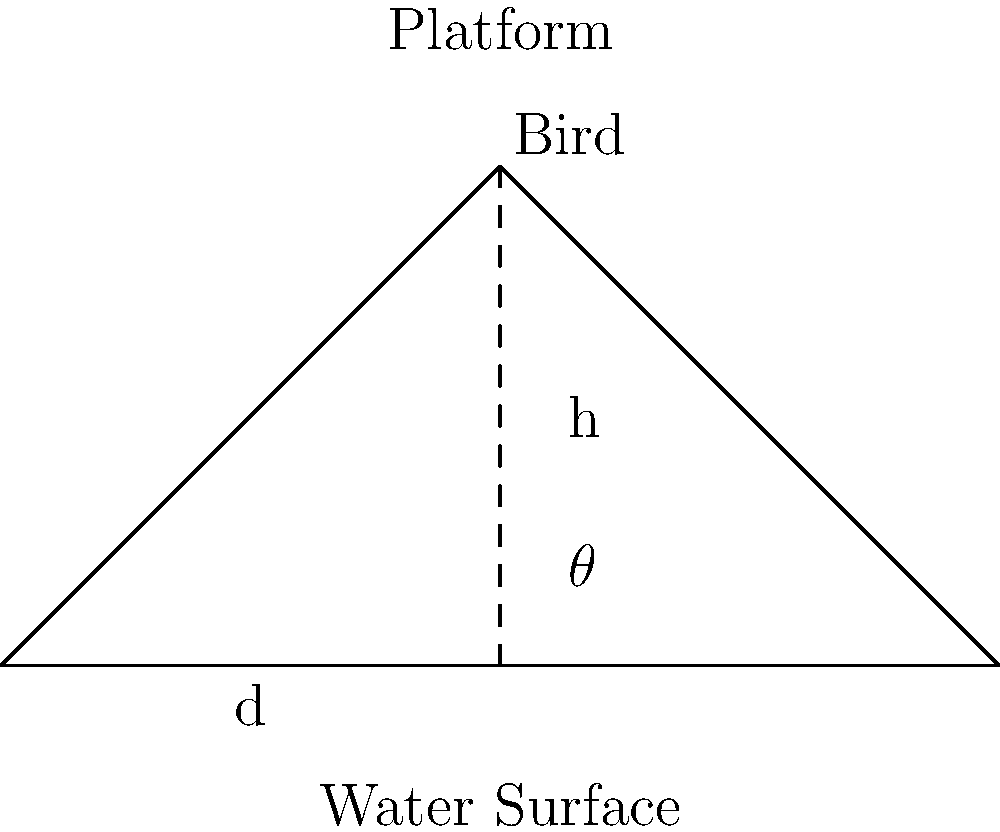From an elevated platform overlooking a lake in Winter Haven, you're observing water birds. If the platform is at a height h above the water surface and the closest observable bird is at a horizontal distance d from the base of the platform, what is the optimal viewing angle $\theta$ (in degrees) to maximize your view of the bird? To find the optimal viewing angle, we'll follow these steps:

1. Recognize that the situation forms a right-angled triangle, with:
   - The platform height (h) as the opposite side
   - The horizontal distance to the bird (d) as the adjacent side
   - The line of sight to the bird as the hypotenuse

2. The angle $\theta$ is formed between the horizontal (water surface) and the line of sight.

3. In a right-angled triangle, the tangent of an angle is the ratio of the opposite side to the adjacent side:

   $$\tan(\theta) = \frac{\text{opposite}}{\text{adjacent}} = \frac{h}{d}$$

4. To find $\theta$, we take the inverse tangent (arctangent) of this ratio:

   $$\theta = \arctan\left(\frac{h}{d}\right)$$

5. The optimal viewing angle is when this ratio is 1, meaning $h = d$. This occurs at a 45-degree angle.

   When $\frac{h}{d} = 1$, $\arctan(1) = 45°$

6. At a 45-degree angle, you maximize your view of both the bird and its surrounding environment, balancing the horizontal and vertical components of your field of view.

Therefore, the optimal viewing angle for observing water birds from an elevated platform is 45 degrees.
Answer: 45° 